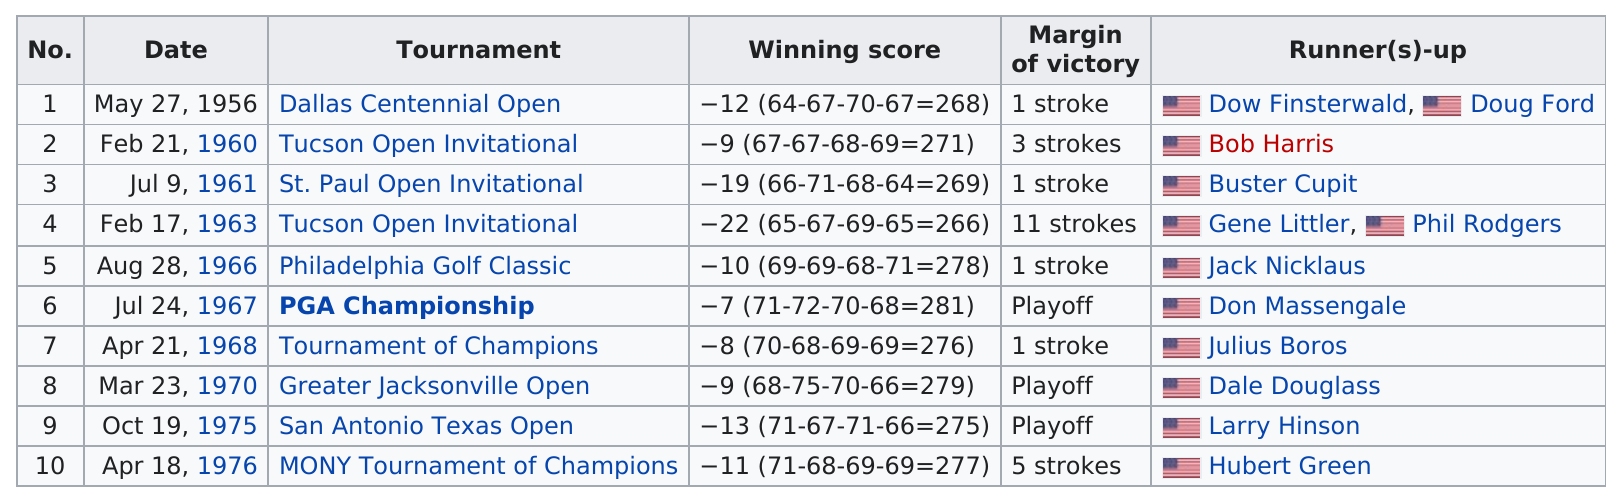Outline some significant characteristics in this image. The margin of victory with the largest stroke count was 11. In the Tucson Open Invitational, he achieved the largest margin of victory, demonstrating his exceptional skills and dominance in the field. Don January won the Tucson Open Invitational twice, in 1960 and 1963. There were one runner-up on July 24, 1967. The margin of victory in the 1963 Tucson Open Invitational was 11 strokes. 